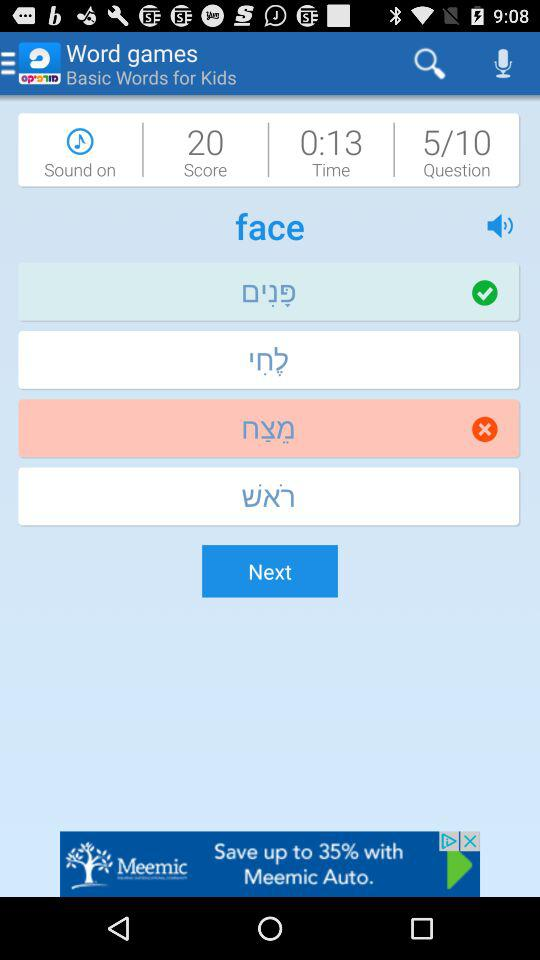How many questions to attempt? The number of questions to attempt is 10. 